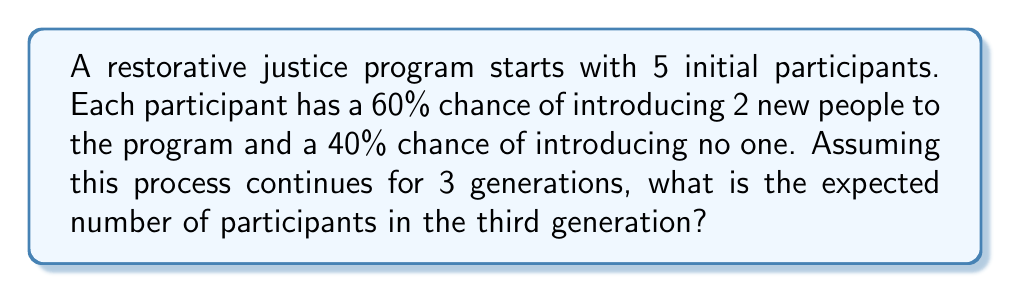Can you answer this question? Let's approach this step-by-step using the concept of branching processes:

1) First, we need to calculate the expected number of new participants introduced by each person:
   $E[X] = 2 \cdot 0.60 + 0 \cdot 0.40 = 1.2$

2) This means that, on average, each participant introduces 1.2 new people to the program.

3) Now, let's calculate the expected number of participants in each generation:
   - 1st generation (initial): 5
   - 2nd generation: $5 \cdot 1.2 = 6$
   - 3rd generation: $6 \cdot 1.2 = 7.2$

4) The expected number of participants in the third generation is 7.2.

5) However, since we're dealing with whole people, we need to round this to the nearest integer.

Therefore, the expected number of participants in the third generation is 7.
Answer: 7 participants 